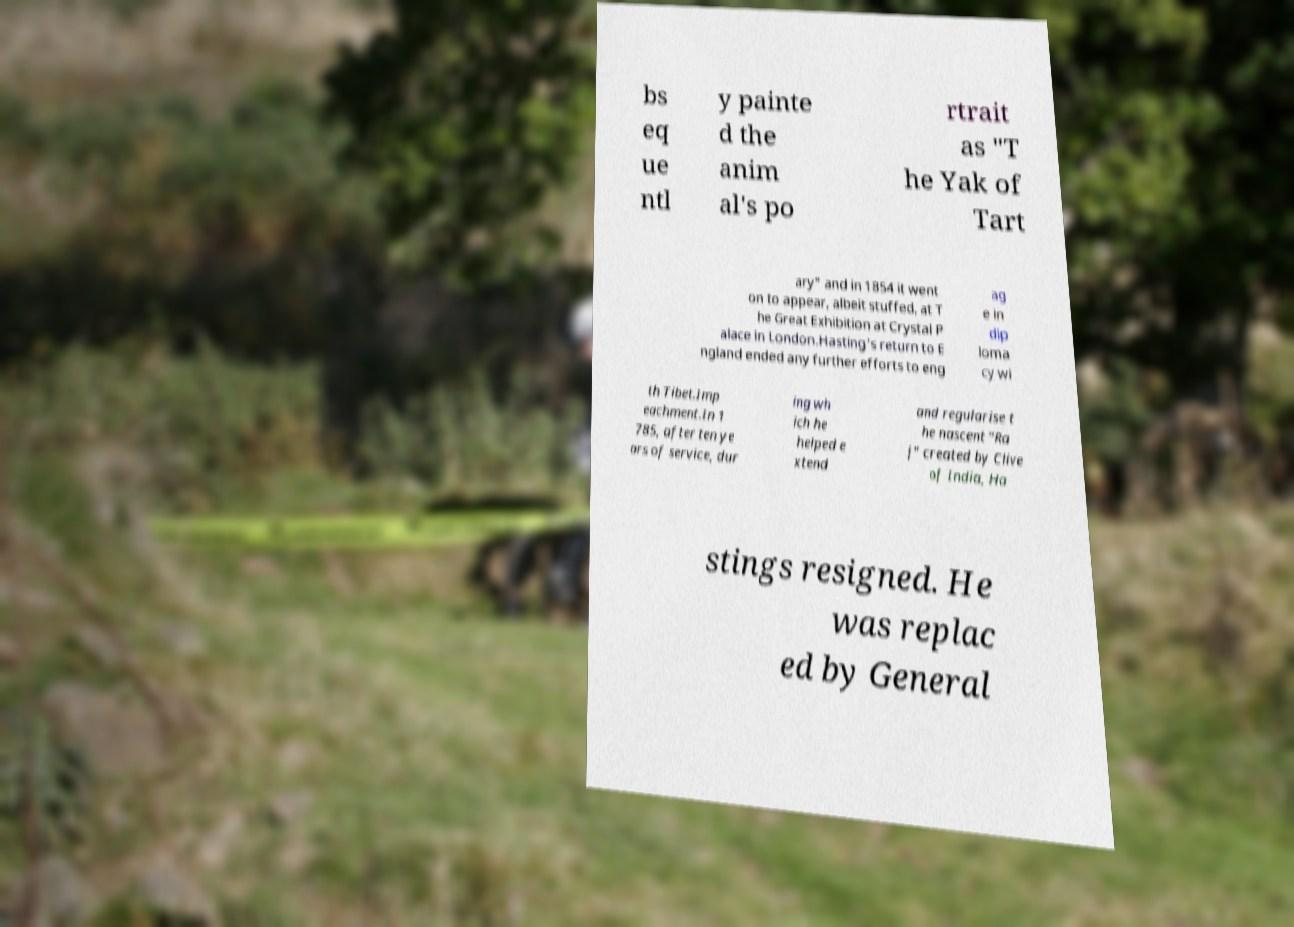For documentation purposes, I need the text within this image transcribed. Could you provide that? bs eq ue ntl y painte d the anim al's po rtrait as "T he Yak of Tart ary" and in 1854 it went on to appear, albeit stuffed, at T he Great Exhibition at Crystal P alace in London.Hasting's return to E ngland ended any further efforts to eng ag e in dip loma cy wi th Tibet.Imp eachment.In 1 785, after ten ye ars of service, dur ing wh ich he helped e xtend and regularise t he nascent "Ra j" created by Clive of India, Ha stings resigned. He was replac ed by General 